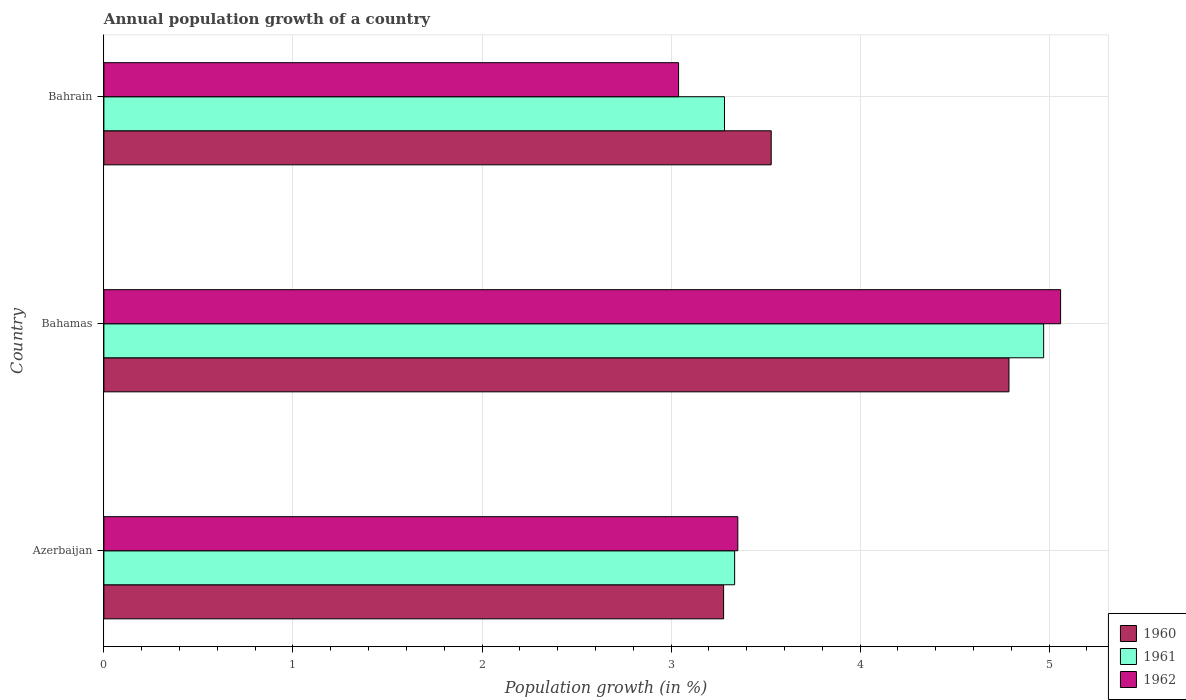Are the number of bars per tick equal to the number of legend labels?
Your response must be concise. Yes. Are the number of bars on each tick of the Y-axis equal?
Give a very brief answer. Yes. How many bars are there on the 2nd tick from the bottom?
Offer a very short reply. 3. What is the label of the 2nd group of bars from the top?
Make the answer very short. Bahamas. What is the annual population growth in 1960 in Azerbaijan?
Keep it short and to the point. 3.28. Across all countries, what is the maximum annual population growth in 1962?
Make the answer very short. 5.06. Across all countries, what is the minimum annual population growth in 1960?
Keep it short and to the point. 3.28. In which country was the annual population growth in 1962 maximum?
Your answer should be compact. Bahamas. In which country was the annual population growth in 1960 minimum?
Provide a succinct answer. Azerbaijan. What is the total annual population growth in 1960 in the graph?
Provide a short and direct response. 11.6. What is the difference between the annual population growth in 1961 in Bahamas and that in Bahrain?
Give a very brief answer. 1.69. What is the difference between the annual population growth in 1960 in Bahamas and the annual population growth in 1961 in Azerbaijan?
Your response must be concise. 1.45. What is the average annual population growth in 1962 per country?
Offer a very short reply. 3.82. What is the difference between the annual population growth in 1960 and annual population growth in 1961 in Bahamas?
Make the answer very short. -0.18. What is the ratio of the annual population growth in 1960 in Bahamas to that in Bahrain?
Keep it short and to the point. 1.36. Is the annual population growth in 1961 in Bahamas less than that in Bahrain?
Provide a short and direct response. No. What is the difference between the highest and the second highest annual population growth in 1962?
Provide a succinct answer. 1.71. What is the difference between the highest and the lowest annual population growth in 1960?
Your answer should be compact. 1.51. In how many countries, is the annual population growth in 1960 greater than the average annual population growth in 1960 taken over all countries?
Offer a very short reply. 1. Is the sum of the annual population growth in 1960 in Azerbaijan and Bahrain greater than the maximum annual population growth in 1961 across all countries?
Ensure brevity in your answer.  Yes. What does the 2nd bar from the top in Azerbaijan represents?
Provide a short and direct response. 1961. Is it the case that in every country, the sum of the annual population growth in 1960 and annual population growth in 1961 is greater than the annual population growth in 1962?
Your answer should be very brief. Yes. How many bars are there?
Provide a short and direct response. 9. How many countries are there in the graph?
Offer a terse response. 3. What is the difference between two consecutive major ticks on the X-axis?
Your response must be concise. 1. Are the values on the major ticks of X-axis written in scientific E-notation?
Your answer should be compact. No. Does the graph contain any zero values?
Provide a succinct answer. No. Does the graph contain grids?
Provide a short and direct response. Yes. Where does the legend appear in the graph?
Provide a succinct answer. Bottom right. What is the title of the graph?
Provide a succinct answer. Annual population growth of a country. Does "1975" appear as one of the legend labels in the graph?
Ensure brevity in your answer.  No. What is the label or title of the X-axis?
Your response must be concise. Population growth (in %). What is the Population growth (in %) of 1960 in Azerbaijan?
Your response must be concise. 3.28. What is the Population growth (in %) in 1961 in Azerbaijan?
Provide a succinct answer. 3.34. What is the Population growth (in %) in 1962 in Azerbaijan?
Keep it short and to the point. 3.35. What is the Population growth (in %) in 1960 in Bahamas?
Your answer should be very brief. 4.79. What is the Population growth (in %) of 1961 in Bahamas?
Provide a succinct answer. 4.97. What is the Population growth (in %) in 1962 in Bahamas?
Provide a short and direct response. 5.06. What is the Population growth (in %) in 1960 in Bahrain?
Keep it short and to the point. 3.53. What is the Population growth (in %) of 1961 in Bahrain?
Give a very brief answer. 3.28. What is the Population growth (in %) of 1962 in Bahrain?
Your answer should be very brief. 3.04. Across all countries, what is the maximum Population growth (in %) in 1960?
Ensure brevity in your answer.  4.79. Across all countries, what is the maximum Population growth (in %) in 1961?
Keep it short and to the point. 4.97. Across all countries, what is the maximum Population growth (in %) in 1962?
Offer a terse response. 5.06. Across all countries, what is the minimum Population growth (in %) in 1960?
Provide a short and direct response. 3.28. Across all countries, what is the minimum Population growth (in %) of 1961?
Your answer should be compact. 3.28. Across all countries, what is the minimum Population growth (in %) of 1962?
Offer a terse response. 3.04. What is the total Population growth (in %) in 1960 in the graph?
Ensure brevity in your answer.  11.6. What is the total Population growth (in %) of 1961 in the graph?
Keep it short and to the point. 11.59. What is the total Population growth (in %) in 1962 in the graph?
Provide a succinct answer. 11.45. What is the difference between the Population growth (in %) of 1960 in Azerbaijan and that in Bahamas?
Make the answer very short. -1.51. What is the difference between the Population growth (in %) in 1961 in Azerbaijan and that in Bahamas?
Offer a terse response. -1.63. What is the difference between the Population growth (in %) of 1962 in Azerbaijan and that in Bahamas?
Provide a succinct answer. -1.71. What is the difference between the Population growth (in %) in 1960 in Azerbaijan and that in Bahrain?
Your answer should be compact. -0.25. What is the difference between the Population growth (in %) of 1961 in Azerbaijan and that in Bahrain?
Offer a very short reply. 0.05. What is the difference between the Population growth (in %) in 1962 in Azerbaijan and that in Bahrain?
Make the answer very short. 0.31. What is the difference between the Population growth (in %) in 1960 in Bahamas and that in Bahrain?
Your answer should be compact. 1.26. What is the difference between the Population growth (in %) in 1961 in Bahamas and that in Bahrain?
Keep it short and to the point. 1.69. What is the difference between the Population growth (in %) of 1962 in Bahamas and that in Bahrain?
Your answer should be very brief. 2.02. What is the difference between the Population growth (in %) in 1960 in Azerbaijan and the Population growth (in %) in 1961 in Bahamas?
Offer a very short reply. -1.69. What is the difference between the Population growth (in %) in 1960 in Azerbaijan and the Population growth (in %) in 1962 in Bahamas?
Your response must be concise. -1.78. What is the difference between the Population growth (in %) of 1961 in Azerbaijan and the Population growth (in %) of 1962 in Bahamas?
Your response must be concise. -1.72. What is the difference between the Population growth (in %) in 1960 in Azerbaijan and the Population growth (in %) in 1961 in Bahrain?
Provide a short and direct response. -0. What is the difference between the Population growth (in %) in 1960 in Azerbaijan and the Population growth (in %) in 1962 in Bahrain?
Offer a very short reply. 0.24. What is the difference between the Population growth (in %) of 1961 in Azerbaijan and the Population growth (in %) of 1962 in Bahrain?
Offer a very short reply. 0.3. What is the difference between the Population growth (in %) of 1960 in Bahamas and the Population growth (in %) of 1961 in Bahrain?
Your response must be concise. 1.5. What is the difference between the Population growth (in %) in 1960 in Bahamas and the Population growth (in %) in 1962 in Bahrain?
Provide a succinct answer. 1.75. What is the difference between the Population growth (in %) of 1961 in Bahamas and the Population growth (in %) of 1962 in Bahrain?
Offer a terse response. 1.93. What is the average Population growth (in %) in 1960 per country?
Your answer should be compact. 3.87. What is the average Population growth (in %) in 1961 per country?
Provide a short and direct response. 3.86. What is the average Population growth (in %) in 1962 per country?
Your response must be concise. 3.82. What is the difference between the Population growth (in %) in 1960 and Population growth (in %) in 1961 in Azerbaijan?
Make the answer very short. -0.06. What is the difference between the Population growth (in %) of 1960 and Population growth (in %) of 1962 in Azerbaijan?
Give a very brief answer. -0.08. What is the difference between the Population growth (in %) of 1961 and Population growth (in %) of 1962 in Azerbaijan?
Provide a succinct answer. -0.02. What is the difference between the Population growth (in %) in 1960 and Population growth (in %) in 1961 in Bahamas?
Provide a short and direct response. -0.18. What is the difference between the Population growth (in %) in 1960 and Population growth (in %) in 1962 in Bahamas?
Give a very brief answer. -0.27. What is the difference between the Population growth (in %) in 1961 and Population growth (in %) in 1962 in Bahamas?
Make the answer very short. -0.09. What is the difference between the Population growth (in %) of 1960 and Population growth (in %) of 1961 in Bahrain?
Provide a short and direct response. 0.25. What is the difference between the Population growth (in %) in 1960 and Population growth (in %) in 1962 in Bahrain?
Ensure brevity in your answer.  0.49. What is the difference between the Population growth (in %) of 1961 and Population growth (in %) of 1962 in Bahrain?
Provide a succinct answer. 0.24. What is the ratio of the Population growth (in %) in 1960 in Azerbaijan to that in Bahamas?
Make the answer very short. 0.68. What is the ratio of the Population growth (in %) of 1961 in Azerbaijan to that in Bahamas?
Provide a succinct answer. 0.67. What is the ratio of the Population growth (in %) in 1962 in Azerbaijan to that in Bahamas?
Make the answer very short. 0.66. What is the ratio of the Population growth (in %) in 1960 in Azerbaijan to that in Bahrain?
Give a very brief answer. 0.93. What is the ratio of the Population growth (in %) in 1961 in Azerbaijan to that in Bahrain?
Give a very brief answer. 1.02. What is the ratio of the Population growth (in %) of 1962 in Azerbaijan to that in Bahrain?
Provide a succinct answer. 1.1. What is the ratio of the Population growth (in %) of 1960 in Bahamas to that in Bahrain?
Provide a short and direct response. 1.36. What is the ratio of the Population growth (in %) in 1961 in Bahamas to that in Bahrain?
Provide a succinct answer. 1.51. What is the ratio of the Population growth (in %) in 1962 in Bahamas to that in Bahrain?
Provide a short and direct response. 1.66. What is the difference between the highest and the second highest Population growth (in %) of 1960?
Keep it short and to the point. 1.26. What is the difference between the highest and the second highest Population growth (in %) of 1961?
Provide a short and direct response. 1.63. What is the difference between the highest and the second highest Population growth (in %) of 1962?
Provide a short and direct response. 1.71. What is the difference between the highest and the lowest Population growth (in %) of 1960?
Offer a very short reply. 1.51. What is the difference between the highest and the lowest Population growth (in %) in 1961?
Ensure brevity in your answer.  1.69. What is the difference between the highest and the lowest Population growth (in %) in 1962?
Ensure brevity in your answer.  2.02. 